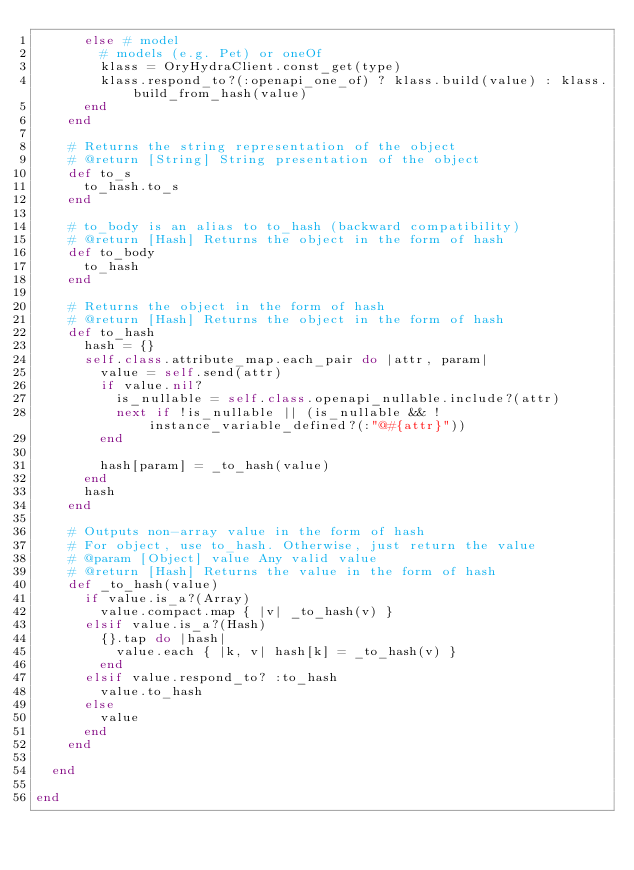Convert code to text. <code><loc_0><loc_0><loc_500><loc_500><_Ruby_>      else # model
        # models (e.g. Pet) or oneOf
        klass = OryHydraClient.const_get(type)
        klass.respond_to?(:openapi_one_of) ? klass.build(value) : klass.build_from_hash(value)
      end
    end

    # Returns the string representation of the object
    # @return [String] String presentation of the object
    def to_s
      to_hash.to_s
    end

    # to_body is an alias to to_hash (backward compatibility)
    # @return [Hash] Returns the object in the form of hash
    def to_body
      to_hash
    end

    # Returns the object in the form of hash
    # @return [Hash] Returns the object in the form of hash
    def to_hash
      hash = {}
      self.class.attribute_map.each_pair do |attr, param|
        value = self.send(attr)
        if value.nil?
          is_nullable = self.class.openapi_nullable.include?(attr)
          next if !is_nullable || (is_nullable && !instance_variable_defined?(:"@#{attr}"))
        end

        hash[param] = _to_hash(value)
      end
      hash
    end

    # Outputs non-array value in the form of hash
    # For object, use to_hash. Otherwise, just return the value
    # @param [Object] value Any valid value
    # @return [Hash] Returns the value in the form of hash
    def _to_hash(value)
      if value.is_a?(Array)
        value.compact.map { |v| _to_hash(v) }
      elsif value.is_a?(Hash)
        {}.tap do |hash|
          value.each { |k, v| hash[k] = _to_hash(v) }
        end
      elsif value.respond_to? :to_hash
        value.to_hash
      else
        value
      end
    end

  end

end
</code> 